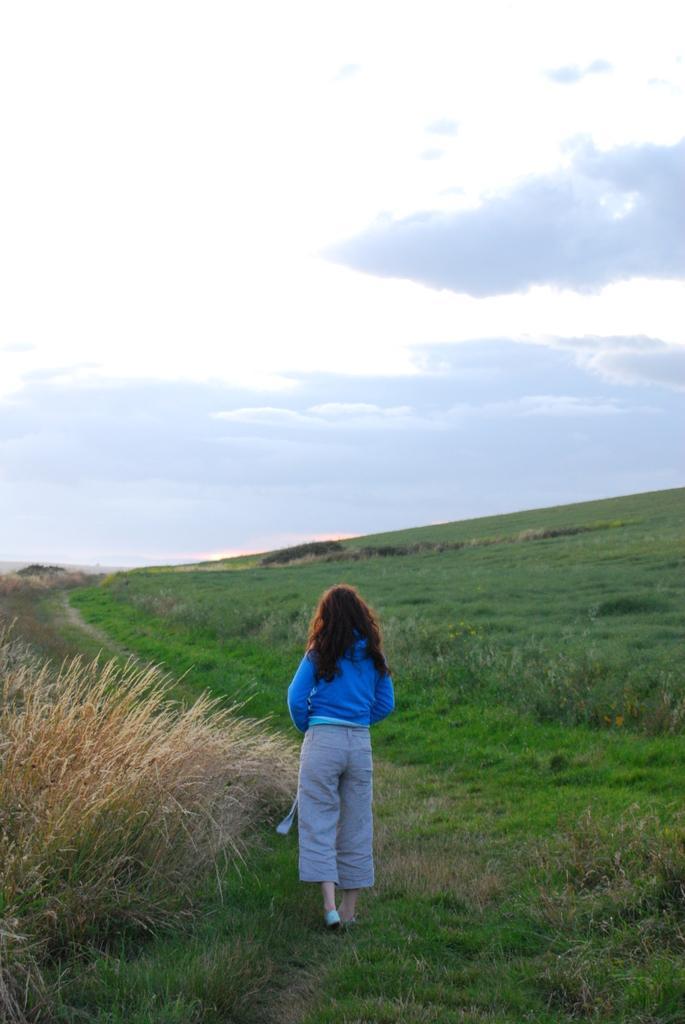Could you give a brief overview of what you see in this image? In this picture there is a girl walking and we can see grass. In the background of the image we can see sky with clouds. 